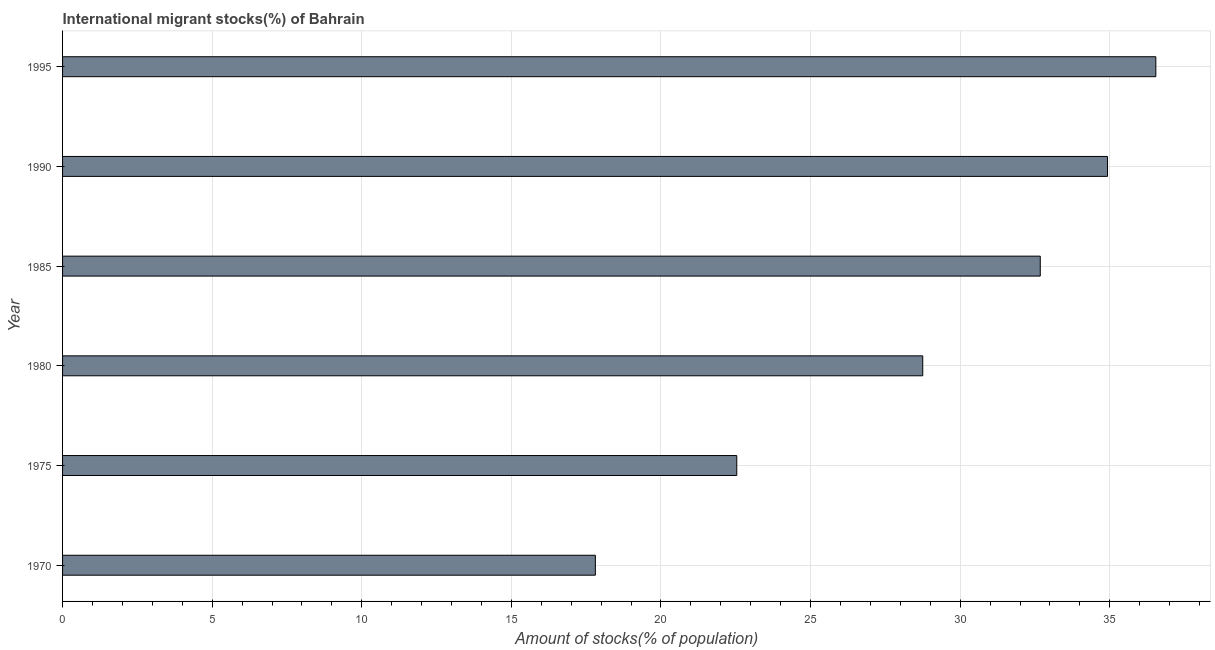Does the graph contain grids?
Your response must be concise. Yes. What is the title of the graph?
Your answer should be compact. International migrant stocks(%) of Bahrain. What is the label or title of the X-axis?
Your answer should be very brief. Amount of stocks(% of population). What is the number of international migrant stocks in 1975?
Keep it short and to the point. 22.53. Across all years, what is the maximum number of international migrant stocks?
Provide a short and direct response. 36.54. Across all years, what is the minimum number of international migrant stocks?
Make the answer very short. 17.81. In which year was the number of international migrant stocks maximum?
Ensure brevity in your answer.  1995. What is the sum of the number of international migrant stocks?
Ensure brevity in your answer.  173.23. What is the difference between the number of international migrant stocks in 1970 and 1990?
Offer a very short reply. -17.12. What is the average number of international migrant stocks per year?
Your answer should be very brief. 28.87. What is the median number of international migrant stocks?
Keep it short and to the point. 30.71. In how many years, is the number of international migrant stocks greater than 14 %?
Provide a succinct answer. 6. Do a majority of the years between 1990 and 1995 (inclusive) have number of international migrant stocks greater than 12 %?
Provide a short and direct response. Yes. What is the ratio of the number of international migrant stocks in 1990 to that in 1995?
Ensure brevity in your answer.  0.96. Is the number of international migrant stocks in 1970 less than that in 1980?
Your response must be concise. Yes. What is the difference between the highest and the second highest number of international migrant stocks?
Your response must be concise. 1.61. Is the sum of the number of international migrant stocks in 1985 and 1990 greater than the maximum number of international migrant stocks across all years?
Your answer should be very brief. Yes. What is the difference between the highest and the lowest number of international migrant stocks?
Offer a very short reply. 18.73. Are all the bars in the graph horizontal?
Your answer should be compact. Yes. How many years are there in the graph?
Offer a very short reply. 6. What is the difference between two consecutive major ticks on the X-axis?
Ensure brevity in your answer.  5. Are the values on the major ticks of X-axis written in scientific E-notation?
Ensure brevity in your answer.  No. What is the Amount of stocks(% of population) in 1970?
Your answer should be very brief. 17.81. What is the Amount of stocks(% of population) of 1975?
Your response must be concise. 22.53. What is the Amount of stocks(% of population) of 1980?
Offer a very short reply. 28.75. What is the Amount of stocks(% of population) of 1985?
Give a very brief answer. 32.68. What is the Amount of stocks(% of population) in 1990?
Your response must be concise. 34.92. What is the Amount of stocks(% of population) of 1995?
Ensure brevity in your answer.  36.54. What is the difference between the Amount of stocks(% of population) in 1970 and 1975?
Give a very brief answer. -4.73. What is the difference between the Amount of stocks(% of population) in 1970 and 1980?
Offer a very short reply. -10.94. What is the difference between the Amount of stocks(% of population) in 1970 and 1985?
Your response must be concise. -14.87. What is the difference between the Amount of stocks(% of population) in 1970 and 1990?
Offer a terse response. -17.12. What is the difference between the Amount of stocks(% of population) in 1970 and 1995?
Give a very brief answer. -18.73. What is the difference between the Amount of stocks(% of population) in 1975 and 1980?
Offer a terse response. -6.22. What is the difference between the Amount of stocks(% of population) in 1975 and 1985?
Your response must be concise. -10.14. What is the difference between the Amount of stocks(% of population) in 1975 and 1990?
Provide a short and direct response. -12.39. What is the difference between the Amount of stocks(% of population) in 1975 and 1995?
Keep it short and to the point. -14.01. What is the difference between the Amount of stocks(% of population) in 1980 and 1985?
Provide a short and direct response. -3.93. What is the difference between the Amount of stocks(% of population) in 1980 and 1990?
Your response must be concise. -6.17. What is the difference between the Amount of stocks(% of population) in 1980 and 1995?
Make the answer very short. -7.79. What is the difference between the Amount of stocks(% of population) in 1985 and 1990?
Provide a short and direct response. -2.25. What is the difference between the Amount of stocks(% of population) in 1985 and 1995?
Keep it short and to the point. -3.86. What is the difference between the Amount of stocks(% of population) in 1990 and 1995?
Your answer should be very brief. -1.61. What is the ratio of the Amount of stocks(% of population) in 1970 to that in 1975?
Keep it short and to the point. 0.79. What is the ratio of the Amount of stocks(% of population) in 1970 to that in 1980?
Your answer should be very brief. 0.62. What is the ratio of the Amount of stocks(% of population) in 1970 to that in 1985?
Keep it short and to the point. 0.55. What is the ratio of the Amount of stocks(% of population) in 1970 to that in 1990?
Ensure brevity in your answer.  0.51. What is the ratio of the Amount of stocks(% of population) in 1970 to that in 1995?
Your response must be concise. 0.49. What is the ratio of the Amount of stocks(% of population) in 1975 to that in 1980?
Offer a very short reply. 0.78. What is the ratio of the Amount of stocks(% of population) in 1975 to that in 1985?
Your answer should be compact. 0.69. What is the ratio of the Amount of stocks(% of population) in 1975 to that in 1990?
Offer a terse response. 0.65. What is the ratio of the Amount of stocks(% of population) in 1975 to that in 1995?
Provide a succinct answer. 0.62. What is the ratio of the Amount of stocks(% of population) in 1980 to that in 1990?
Ensure brevity in your answer.  0.82. What is the ratio of the Amount of stocks(% of population) in 1980 to that in 1995?
Your answer should be very brief. 0.79. What is the ratio of the Amount of stocks(% of population) in 1985 to that in 1990?
Offer a very short reply. 0.94. What is the ratio of the Amount of stocks(% of population) in 1985 to that in 1995?
Provide a succinct answer. 0.89. What is the ratio of the Amount of stocks(% of population) in 1990 to that in 1995?
Your answer should be very brief. 0.96. 